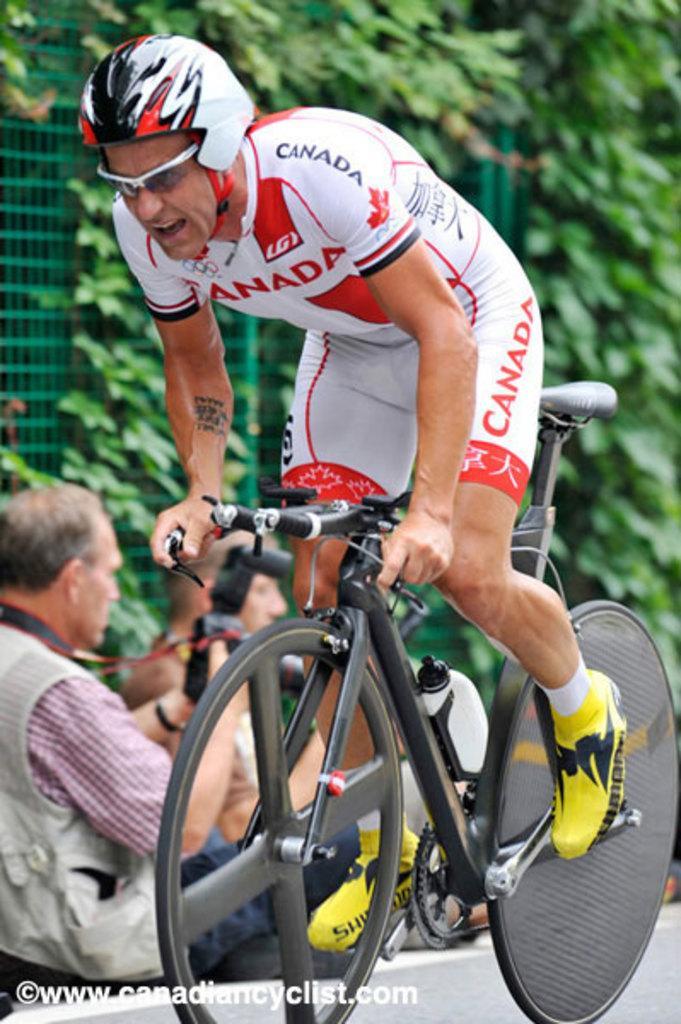Can you describe this image briefly? we can see a person riding a bicycle and we can also see a person sitting on the road ,we can see a creep on the mess. 